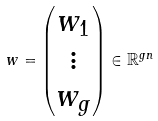Convert formula to latex. <formula><loc_0><loc_0><loc_500><loc_500>w = \begin{pmatrix} w _ { 1 } \\ \vdots \\ w _ { g } \end{pmatrix} \in \mathbb { R } ^ { g n }</formula> 